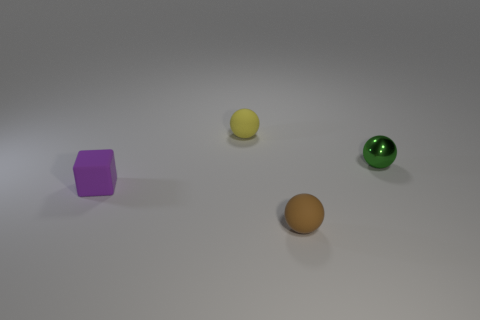Add 3 purple matte things. How many objects exist? 7 Subtract all balls. How many objects are left? 1 Subtract 0 blue balls. How many objects are left? 4 Subtract all gray matte things. Subtract all small purple blocks. How many objects are left? 3 Add 1 spheres. How many spheres are left? 4 Add 3 big metal spheres. How many big metal spheres exist? 3 